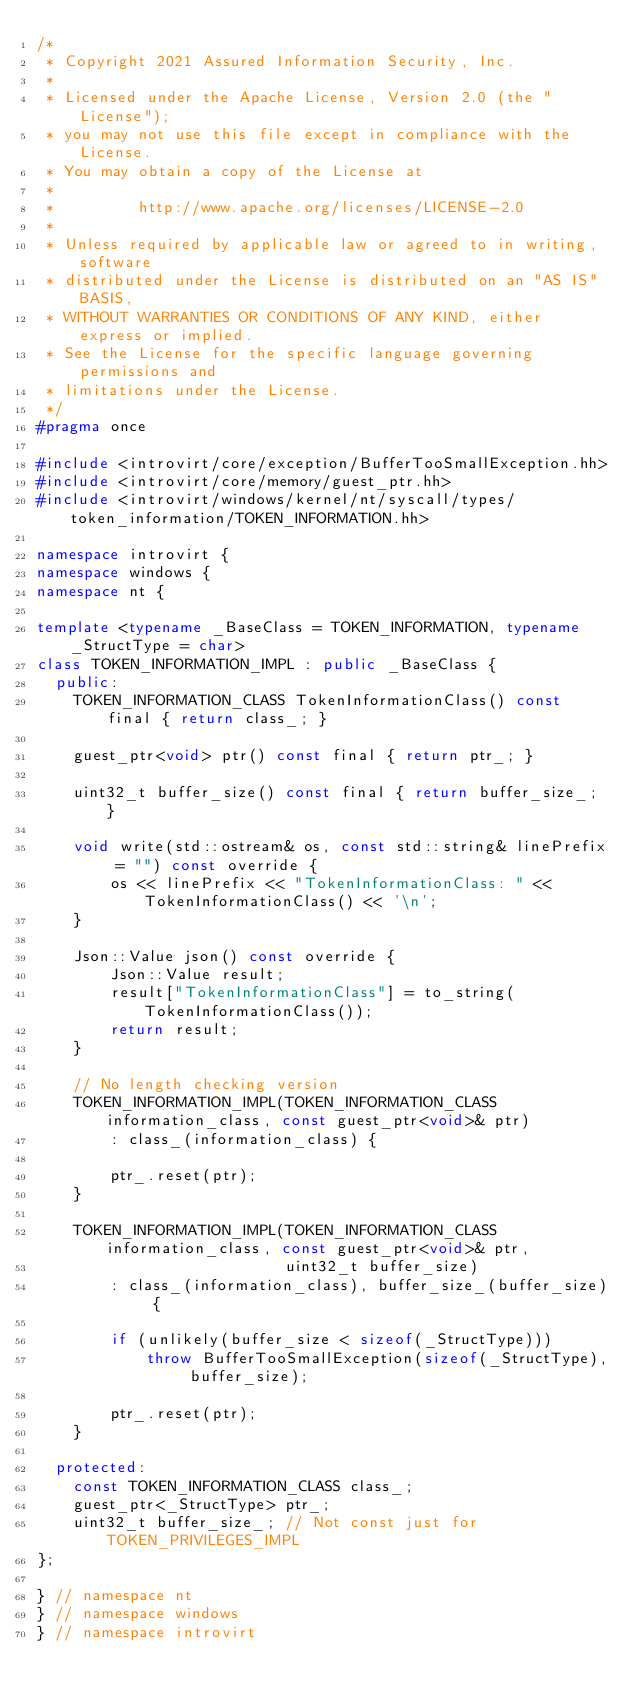Convert code to text. <code><loc_0><loc_0><loc_500><loc_500><_C++_>/*
 * Copyright 2021 Assured Information Security, Inc.
 *
 * Licensed under the Apache License, Version 2.0 (the "License");
 * you may not use this file except in compliance with the License.
 * You may obtain a copy of the License at
 *
 *         http://www.apache.org/licenses/LICENSE-2.0
 *
 * Unless required by applicable law or agreed to in writing, software
 * distributed under the License is distributed on an "AS IS" BASIS,
 * WITHOUT WARRANTIES OR CONDITIONS OF ANY KIND, either express or implied.
 * See the License for the specific language governing permissions and
 * limitations under the License.
 */
#pragma once

#include <introvirt/core/exception/BufferTooSmallException.hh>
#include <introvirt/core/memory/guest_ptr.hh>
#include <introvirt/windows/kernel/nt/syscall/types/token_information/TOKEN_INFORMATION.hh>

namespace introvirt {
namespace windows {
namespace nt {

template <typename _BaseClass = TOKEN_INFORMATION, typename _StructType = char>
class TOKEN_INFORMATION_IMPL : public _BaseClass {
  public:
    TOKEN_INFORMATION_CLASS TokenInformationClass() const final { return class_; }

    guest_ptr<void> ptr() const final { return ptr_; }

    uint32_t buffer_size() const final { return buffer_size_; }

    void write(std::ostream& os, const std::string& linePrefix = "") const override {
        os << linePrefix << "TokenInformationClass: " << TokenInformationClass() << '\n';
    }

    Json::Value json() const override {
        Json::Value result;
        result["TokenInformationClass"] = to_string(TokenInformationClass());
        return result;
    }

    // No length checking version
    TOKEN_INFORMATION_IMPL(TOKEN_INFORMATION_CLASS information_class, const guest_ptr<void>& ptr)
        : class_(information_class) {

        ptr_.reset(ptr);
    }

    TOKEN_INFORMATION_IMPL(TOKEN_INFORMATION_CLASS information_class, const guest_ptr<void>& ptr,
                           uint32_t buffer_size)
        : class_(information_class), buffer_size_(buffer_size) {

        if (unlikely(buffer_size < sizeof(_StructType)))
            throw BufferTooSmallException(sizeof(_StructType), buffer_size);

        ptr_.reset(ptr);
    }

  protected:
    const TOKEN_INFORMATION_CLASS class_;
    guest_ptr<_StructType> ptr_;
    uint32_t buffer_size_; // Not const just for TOKEN_PRIVILEGES_IMPL
};

} // namespace nt
} // namespace windows
} // namespace introvirt</code> 